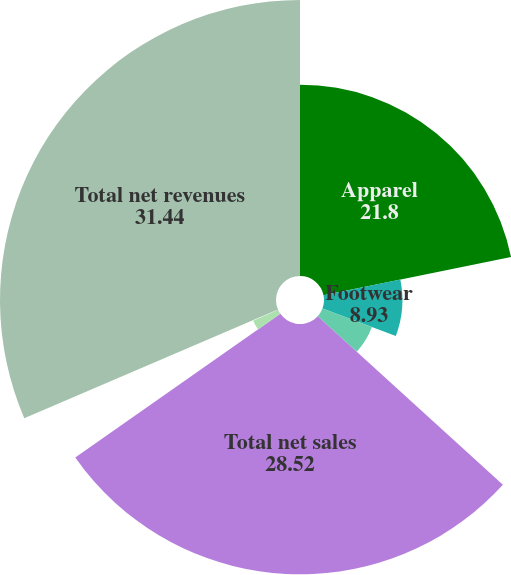Convert chart. <chart><loc_0><loc_0><loc_500><loc_500><pie_chart><fcel>Apparel<fcel>Footwear<fcel>Accessories<fcel>Total net sales<fcel>License revenues<fcel>Connected Fitness<fcel>Total net revenues<nl><fcel>21.8%<fcel>8.93%<fcel>6.02%<fcel>28.52%<fcel>3.1%<fcel>0.18%<fcel>31.44%<nl></chart> 